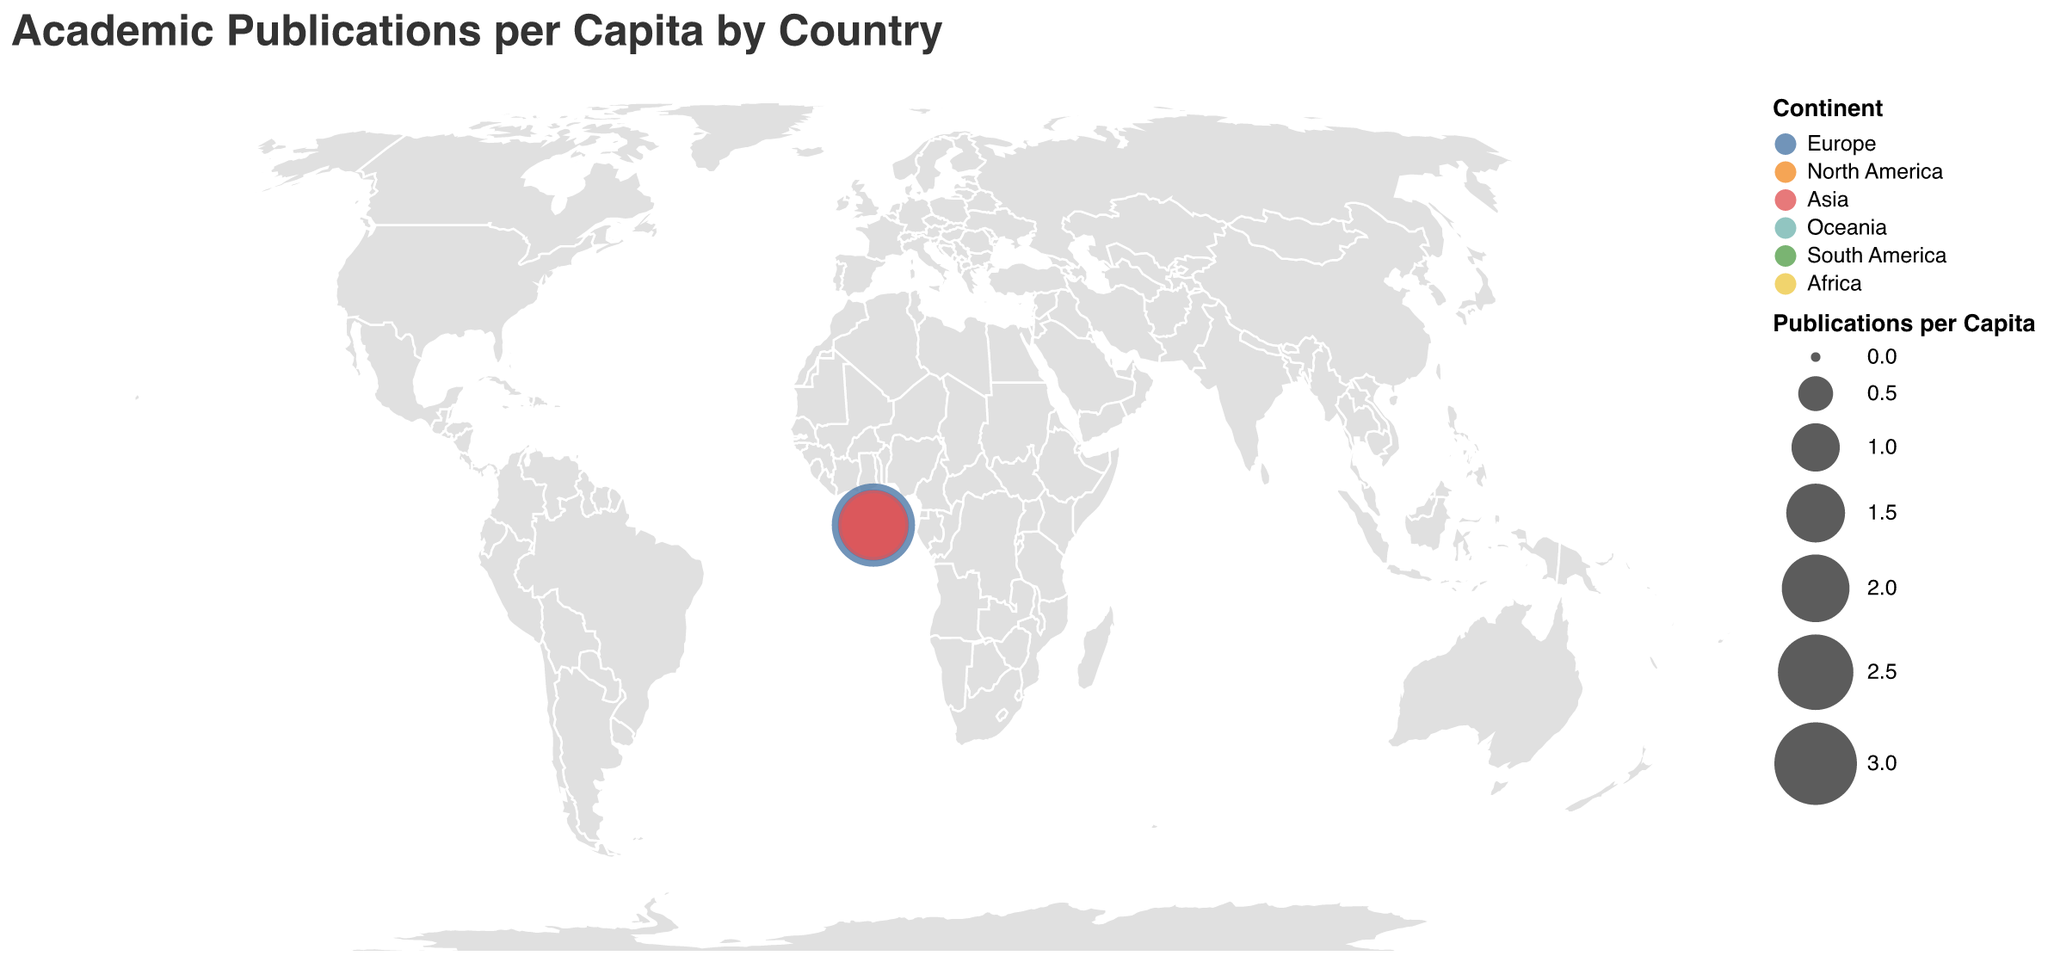What's the title of the figure? The title is typically displayed prominently at the top of the figure and is a straightforward detail to observe.
Answer: Academic Publications per Capita by Country Which country in Oceania has the highest number of academic publications per capita? Oceania is represented by Australia in the data, which shows that Australia has 2.03 publications per capita according to the figure.
Answer: Australia How many continents are represented in the figure? The continents can be identified by the different colors used in the figure. Counting the unique colors/legend items gives the total number of continents.
Answer: 6 Which country in Europe has the highest publications per capita and what is the value? By looking at the European countries in the figure, Switzerland has the largest circle, indicating the highest value.
Answer: Switzerland with 3.05 Identify the country with the lowest publications per capita in Asia. By examining the circles for Asian countries, the smallest circle for Asia is observed for India.
Answer: India Compare the publications per capita between North America and South America. Which continent has a higher average and what is the average value? North America has two countries (United States - 1.32, Canada - 1.47), with an average of (1.32+1.47)/2 = 1.395. South America has one country (Brazil - 0.32), with an average of 0.32. North America has a higher average value.
Answer: North America with 1.395 In Europe, which country has an equal or lower number of publications per capita compared to Japan? Japan has 0.95 publications per capita, and by comparing this value with the European countries, Russia (0.38), and Italy (1.07) are found. Only Russia has a value of 0.38, less than Japan.
Answer: Russia Calculate the difference in publications per capita between the country with the highest and the country with the lowest value. The highest publications per capita is for Switzerland (3.05) and the lowest is for India (0.11). The difference is 3.05 - 0.11.
Answer: 2.94 Which continent has the most countries represented in the figure, and how many countries are there? By counting the number of countries per continent in the figure data: Europe (9), North America (2), Asia (6), Oceania (1), South America (1), and Africa (1). Europe has the highest number of countries.
Answer: Europe with 9 countries What is the publications per capita value for Canada relative to the United States? Is it higher, lower, or equal? By checking the values for Canada (1.47) and the United States (1.32), we see that Canada has a value higher than the United States.
Answer: Higher 